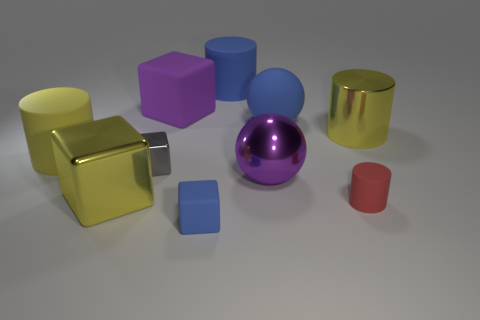There is a big yellow shiny object that is to the left of the metallic object that is behind the big yellow rubber object; how many rubber balls are in front of it?
Offer a very short reply. 0. There is a red rubber cylinder; are there any purple spheres left of it?
Your answer should be very brief. Yes. What number of tiny red cylinders have the same material as the purple cube?
Ensure brevity in your answer.  1. What number of objects are either large yellow shiny blocks or green shiny things?
Keep it short and to the point. 1. Is there a yellow matte block?
Make the answer very short. No. What material is the tiny cube that is behind the large block that is in front of the large yellow metallic cylinder behind the big yellow block made of?
Your answer should be compact. Metal. Is the number of big blue rubber balls to the left of the tiny shiny thing less than the number of cyan metal balls?
Your answer should be compact. No. There is another cube that is the same size as the gray block; what material is it?
Your answer should be compact. Rubber. What is the size of the matte thing that is in front of the big purple metallic object and on the left side of the small cylinder?
Make the answer very short. Small. What size is the rubber thing that is the same shape as the big purple metal thing?
Ensure brevity in your answer.  Large. 